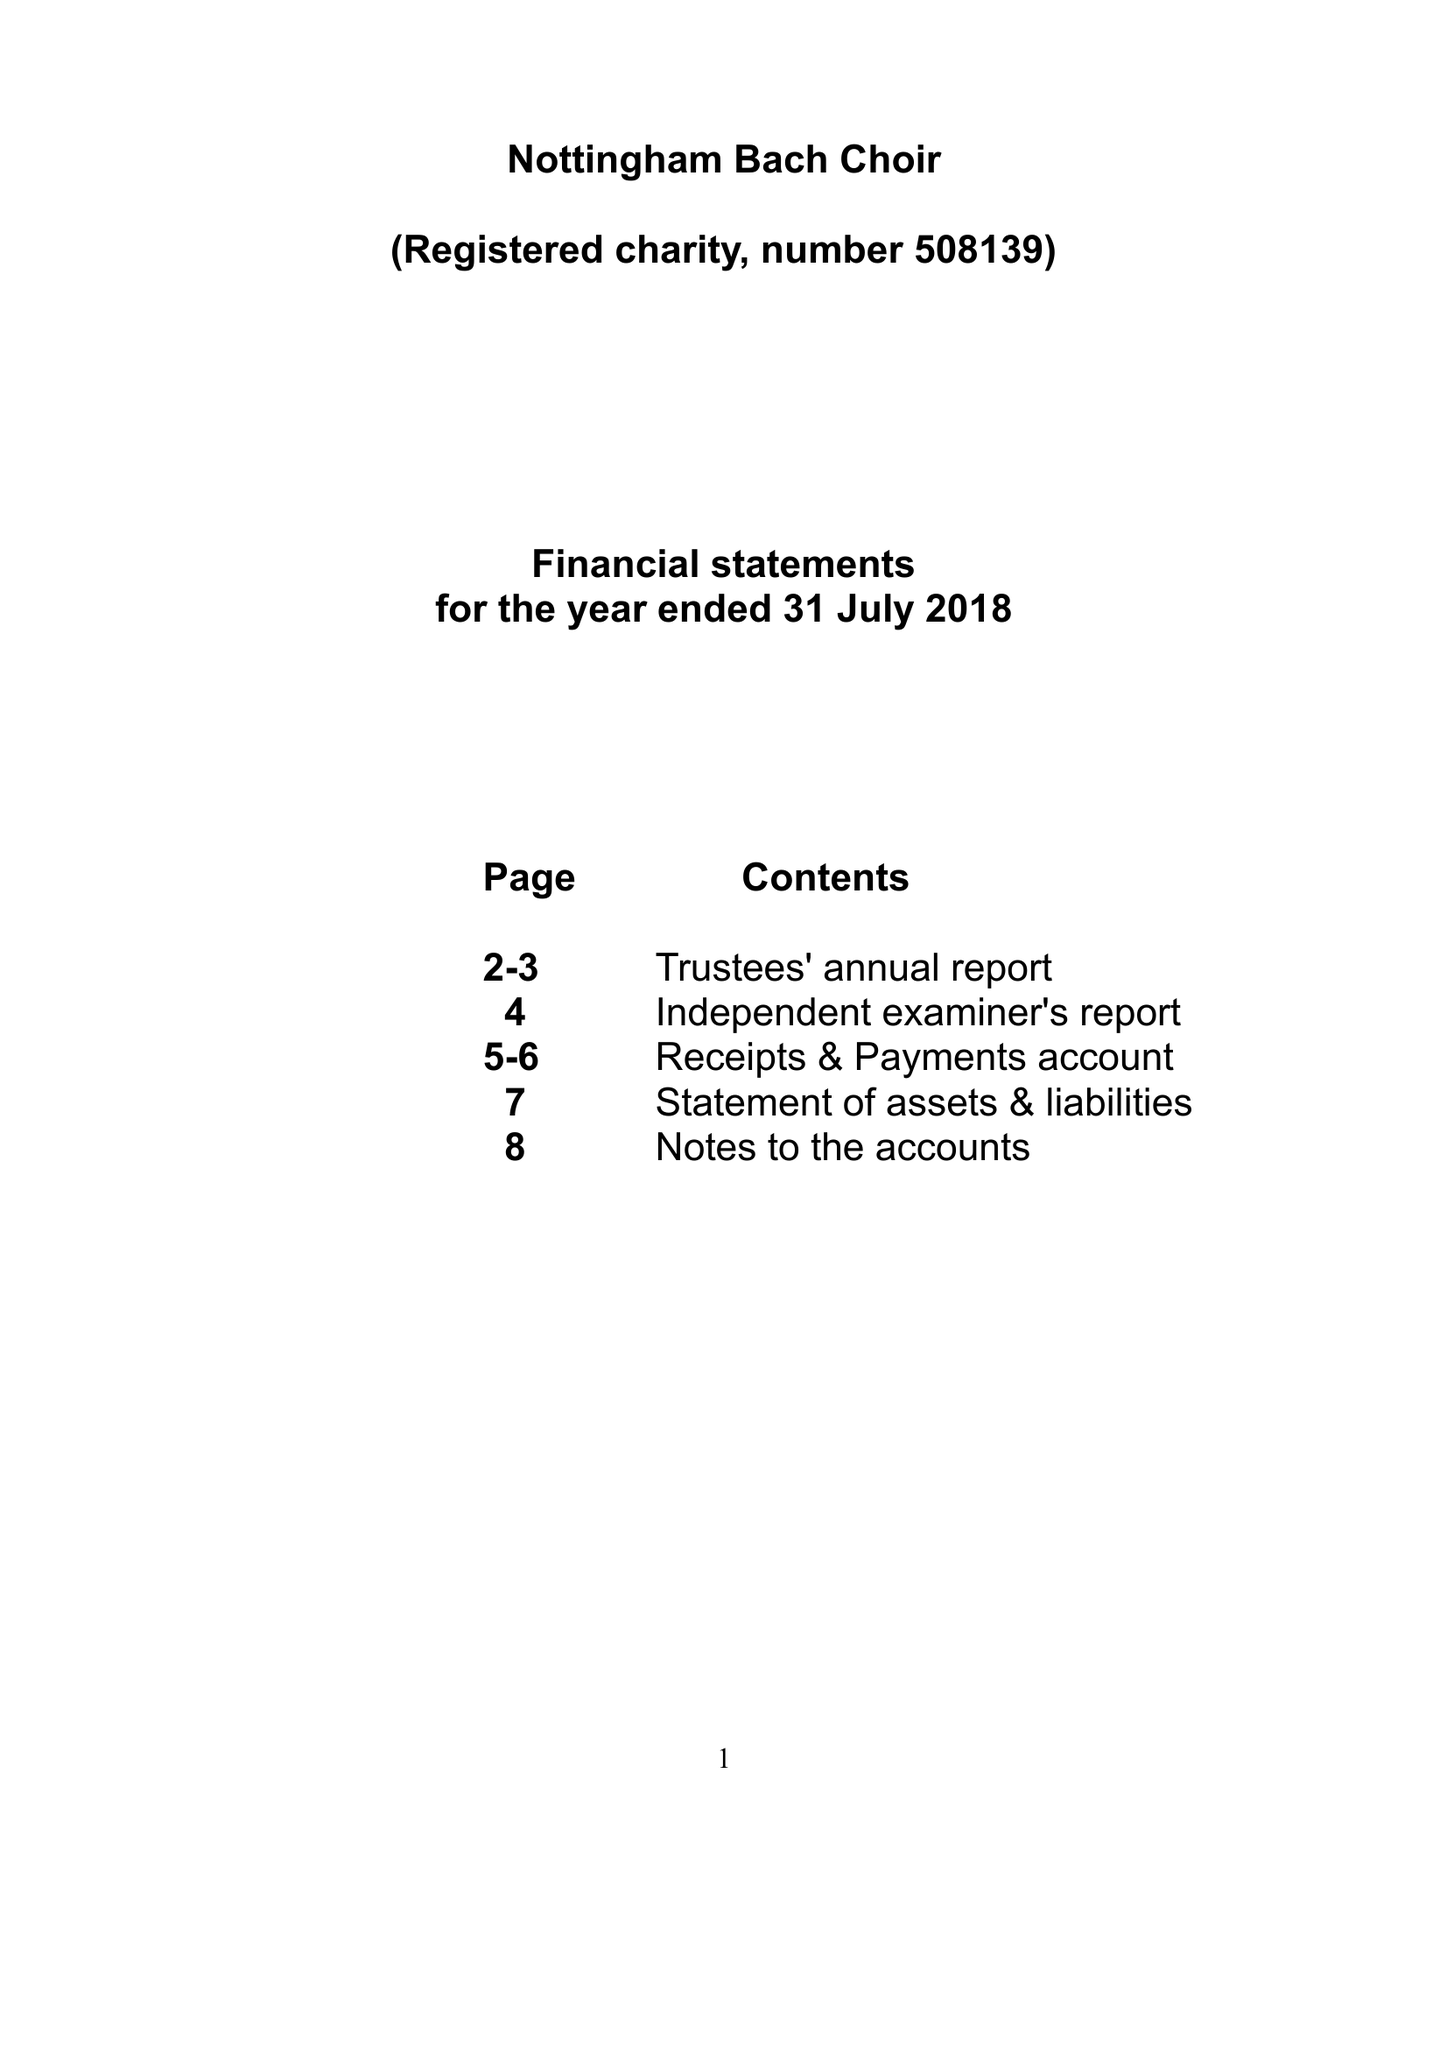What is the value for the report_date?
Answer the question using a single word or phrase. 2018-07-31 